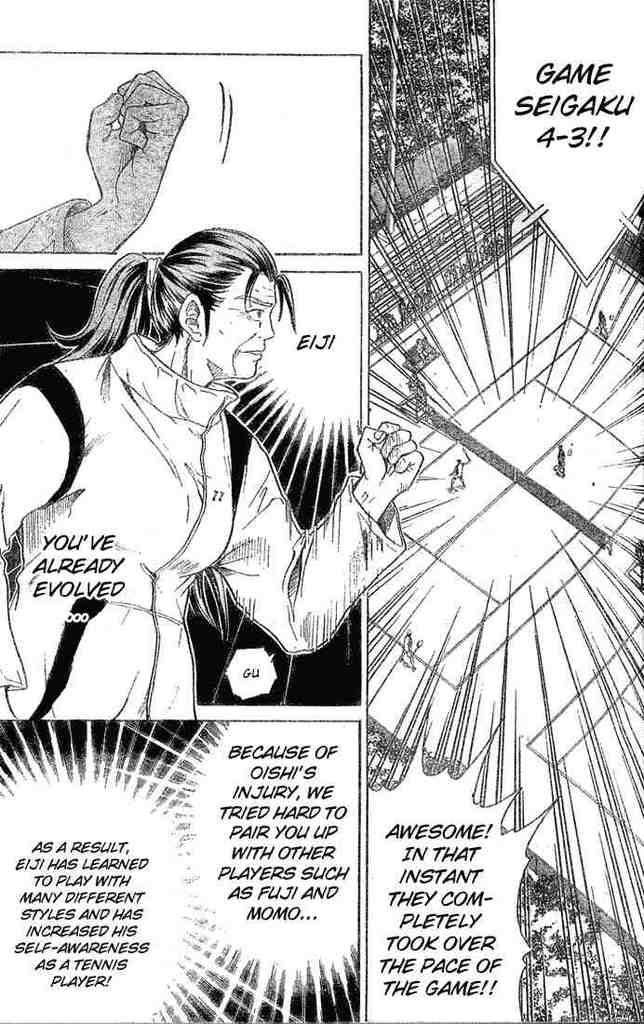What type of image is depicted in the picture? There is a comic art image in the picture. Can you describe the main subject of the image? The image features a woman in the middle. What else can be observed in the image besides the woman? There is text all over the image. What time does the clock in the image show? There is no clock present in the image. What is the caption for the image? The image does not have a caption; it is a comic art piece with text integrated into the artwork. Is the woman in the image a queen? The provided facts do not mention the woman's title or status, so it cannot be determined if she is a queen. 